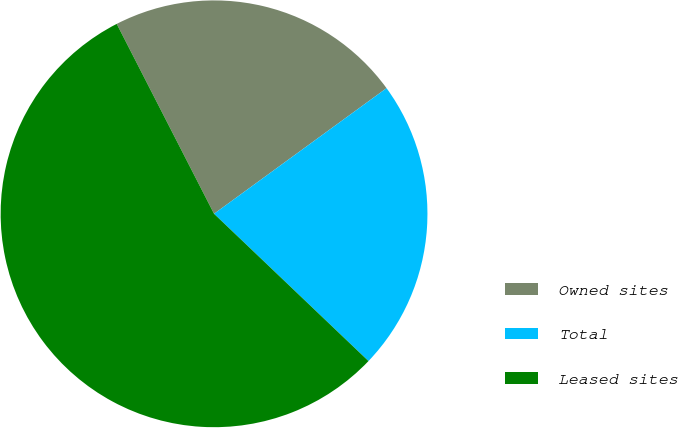<chart> <loc_0><loc_0><loc_500><loc_500><pie_chart><fcel>Owned sites<fcel>Total<fcel>Leased sites<nl><fcel>22.52%<fcel>22.14%<fcel>55.34%<nl></chart> 